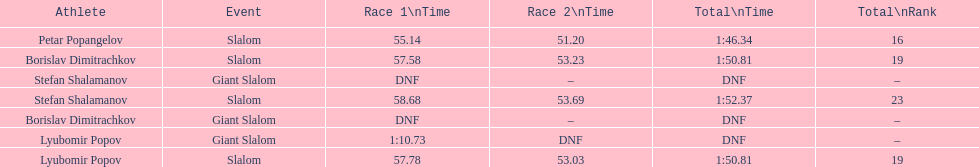What is the number of athletes to finish race one in the giant slalom? 1. 